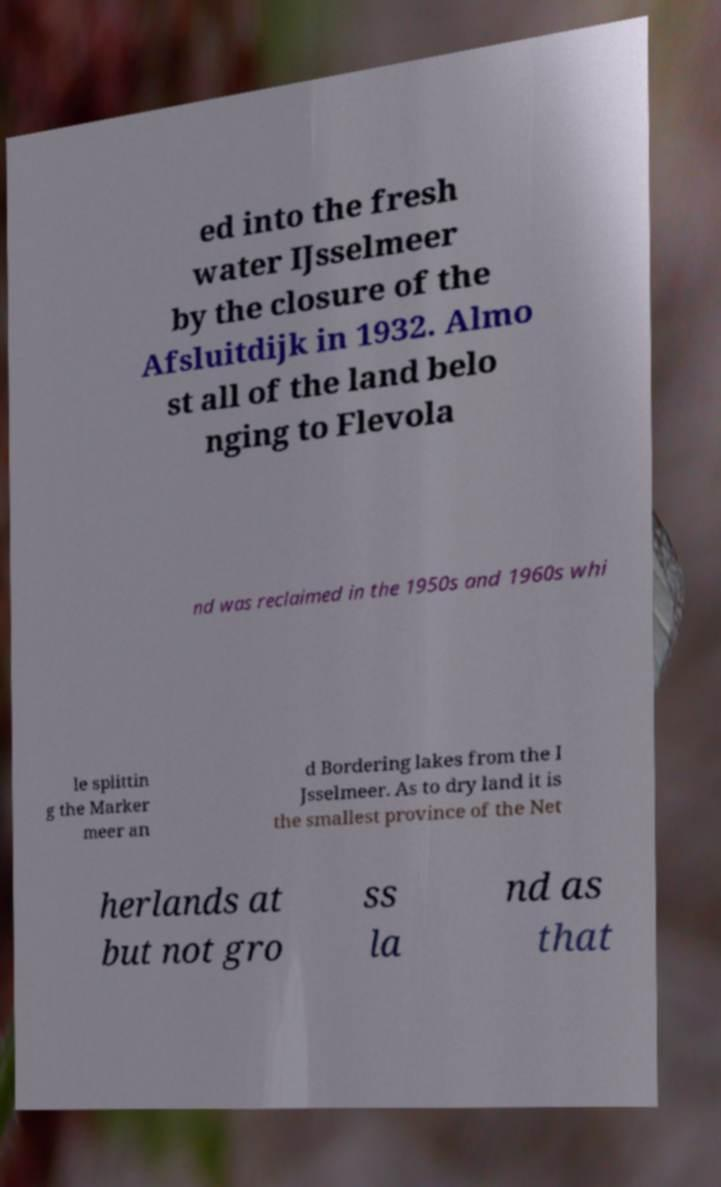For documentation purposes, I need the text within this image transcribed. Could you provide that? ed into the fresh water IJsselmeer by the closure of the Afsluitdijk in 1932. Almo st all of the land belo nging to Flevola nd was reclaimed in the 1950s and 1960s whi le splittin g the Marker meer an d Bordering lakes from the I Jsselmeer. As to dry land it is the smallest province of the Net herlands at but not gro ss la nd as that 